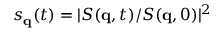<formula> <loc_0><loc_0><loc_500><loc_500>s _ { q } ( t ) = | S ( q , t ) / S ( q , 0 ) | ^ { 2 }</formula> 